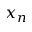<formula> <loc_0><loc_0><loc_500><loc_500>x _ { n }</formula> 